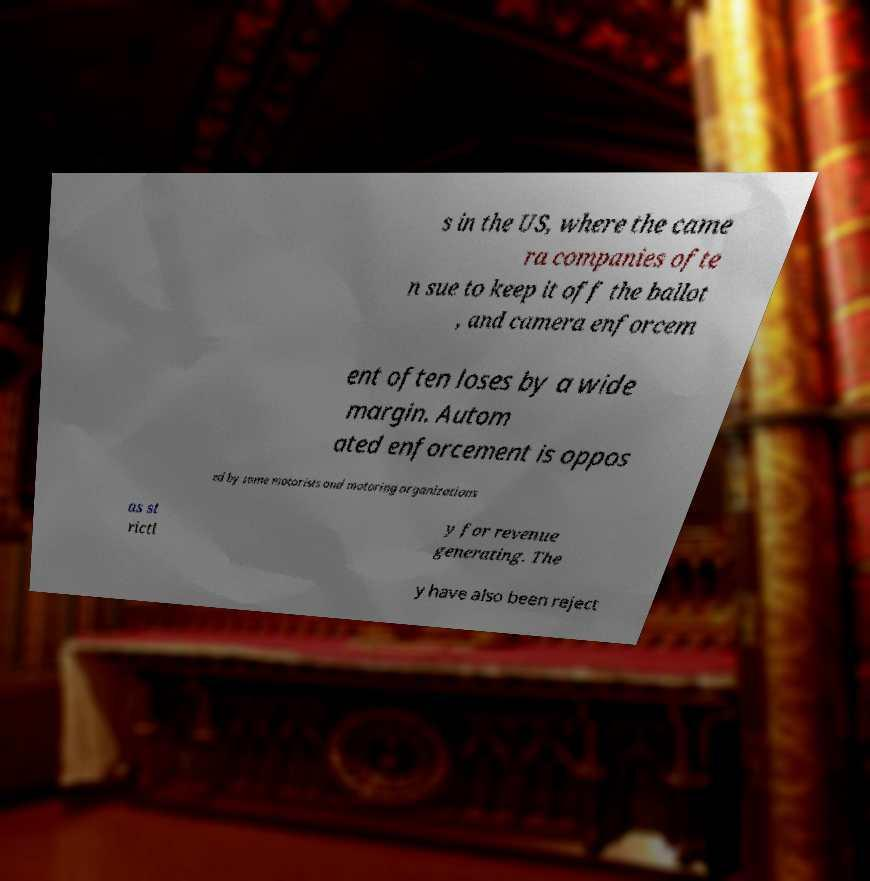What messages or text are displayed in this image? I need them in a readable, typed format. s in the US, where the came ra companies ofte n sue to keep it off the ballot , and camera enforcem ent often loses by a wide margin. Autom ated enforcement is oppos ed by some motorists and motoring organizations as st rictl y for revenue generating. The y have also been reject 